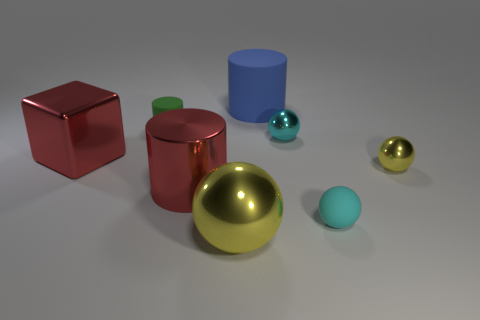What is the size of the metal cylinder that is the same color as the big cube?
Your answer should be compact. Large. Is the number of red metal cylinders less than the number of gray matte things?
Make the answer very short. No. There is a tiny metal sphere behind the large metallic cube; does it have the same color as the small matte sphere?
Your answer should be compact. Yes. What number of yellow blocks have the same size as the cyan metal sphere?
Offer a very short reply. 0. Are there any metallic objects that have the same color as the shiny cylinder?
Ensure brevity in your answer.  Yes. Do the blue object and the tiny cylinder have the same material?
Keep it short and to the point. Yes. What number of other metallic objects are the same shape as the large yellow metallic thing?
Keep it short and to the point. 2. What shape is the small cyan object that is the same material as the small yellow object?
Provide a succinct answer. Sphere. There is a tiny shiny ball in front of the big metallic thing behind the large metallic cylinder; what color is it?
Offer a very short reply. Yellow. Is the color of the cube the same as the big metal cylinder?
Give a very brief answer. Yes. 